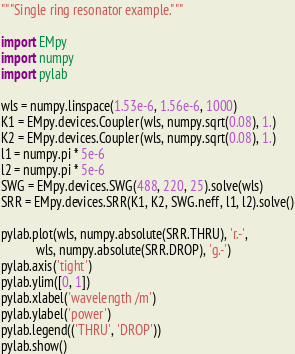<code> <loc_0><loc_0><loc_500><loc_500><_Python_>"""Single ring resonator example."""

import EMpy
import numpy
import pylab

wls = numpy.linspace(1.53e-6, 1.56e-6, 1000)
K1 = EMpy.devices.Coupler(wls, numpy.sqrt(0.08), 1.)
K2 = EMpy.devices.Coupler(wls, numpy.sqrt(0.08), 1.)
l1 = numpy.pi * 5e-6
l2 = numpy.pi * 5e-6
SWG = EMpy.devices.SWG(488, 220, 25).solve(wls)
SRR = EMpy.devices.SRR(K1, K2, SWG.neff, l1, l2).solve()

pylab.plot(wls, numpy.absolute(SRR.THRU), 'r.-',
           wls, numpy.absolute(SRR.DROP), 'g.-')
pylab.axis('tight')
pylab.ylim([0, 1])
pylab.xlabel('wavelength /m')
pylab.ylabel('power')
pylab.legend(('THRU', 'DROP'))
pylab.show()

</code> 